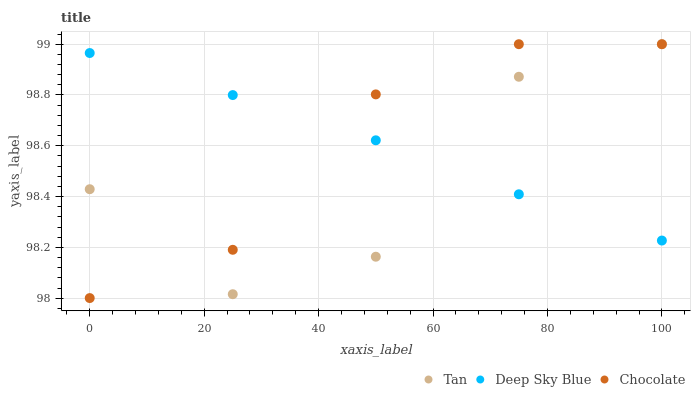Does Tan have the minimum area under the curve?
Answer yes or no. Yes. Does Chocolate have the maximum area under the curve?
Answer yes or no. Yes. Does Deep Sky Blue have the minimum area under the curve?
Answer yes or no. No. Does Deep Sky Blue have the maximum area under the curve?
Answer yes or no. No. Is Deep Sky Blue the smoothest?
Answer yes or no. Yes. Is Tan the roughest?
Answer yes or no. Yes. Is Chocolate the smoothest?
Answer yes or no. No. Is Chocolate the roughest?
Answer yes or no. No. Does Chocolate have the lowest value?
Answer yes or no. Yes. Does Deep Sky Blue have the lowest value?
Answer yes or no. No. Does Chocolate have the highest value?
Answer yes or no. Yes. Does Deep Sky Blue have the highest value?
Answer yes or no. No. Does Tan intersect Deep Sky Blue?
Answer yes or no. Yes. Is Tan less than Deep Sky Blue?
Answer yes or no. No. Is Tan greater than Deep Sky Blue?
Answer yes or no. No. 